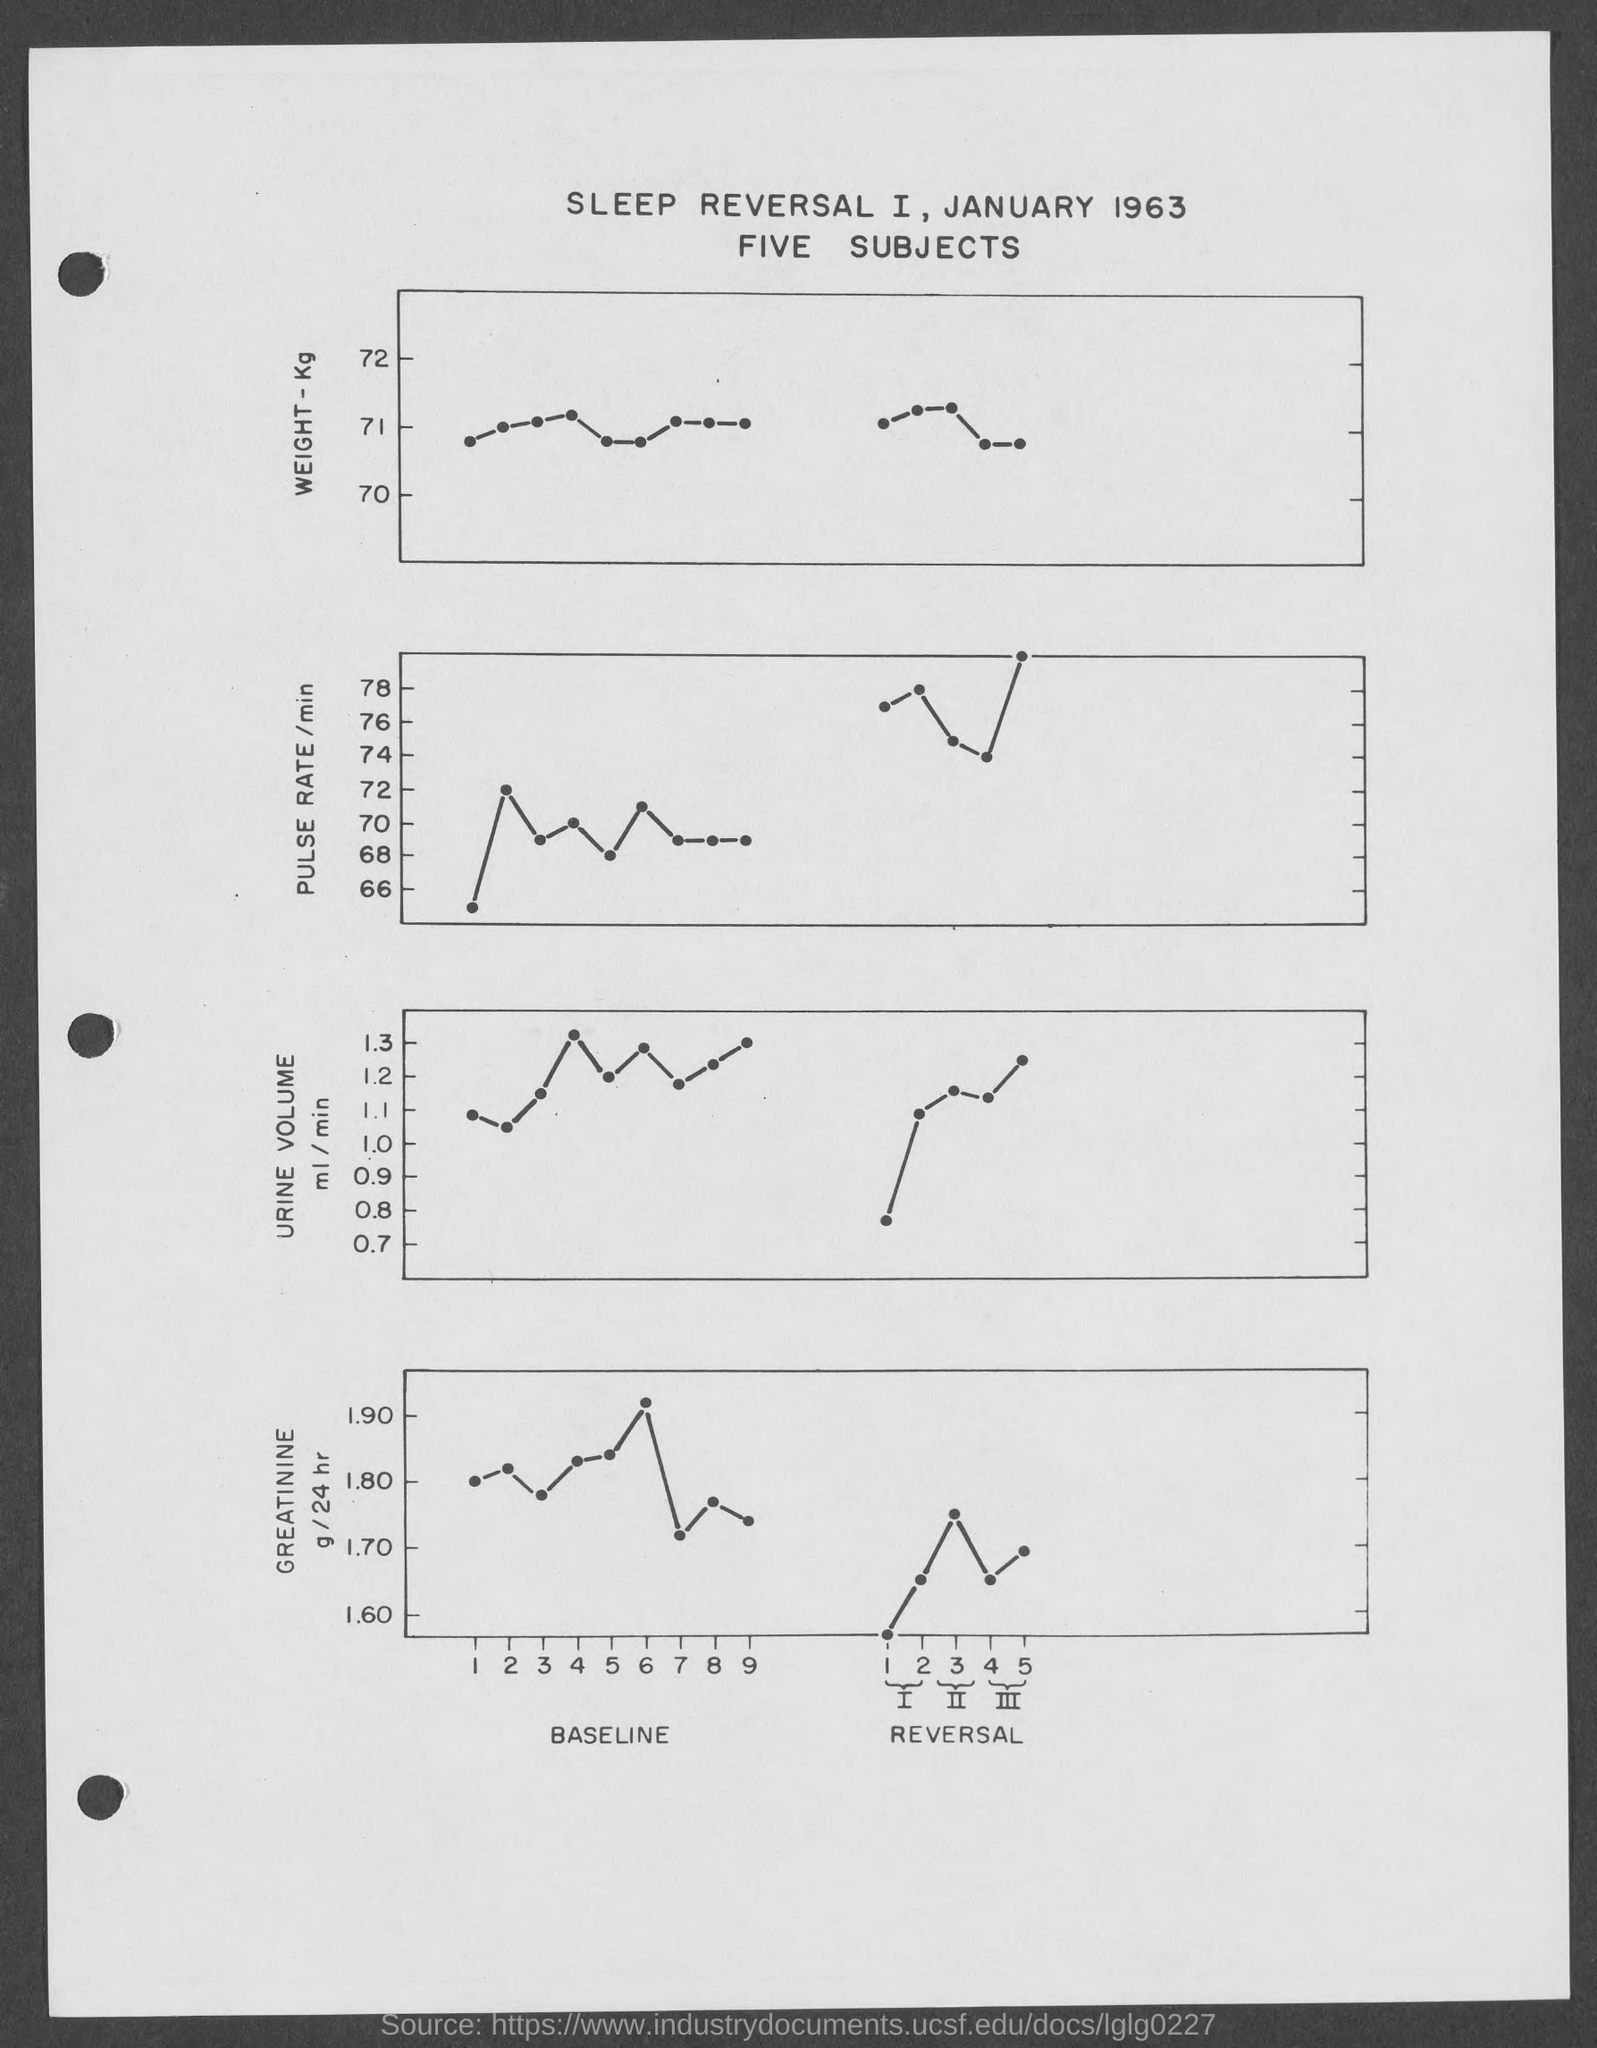What is the year mentioned in the title?
Provide a succinct answer. 1963. What is the attribute plotted along the y axis of the second graph?
Offer a very short reply. Pulse rate /min. 